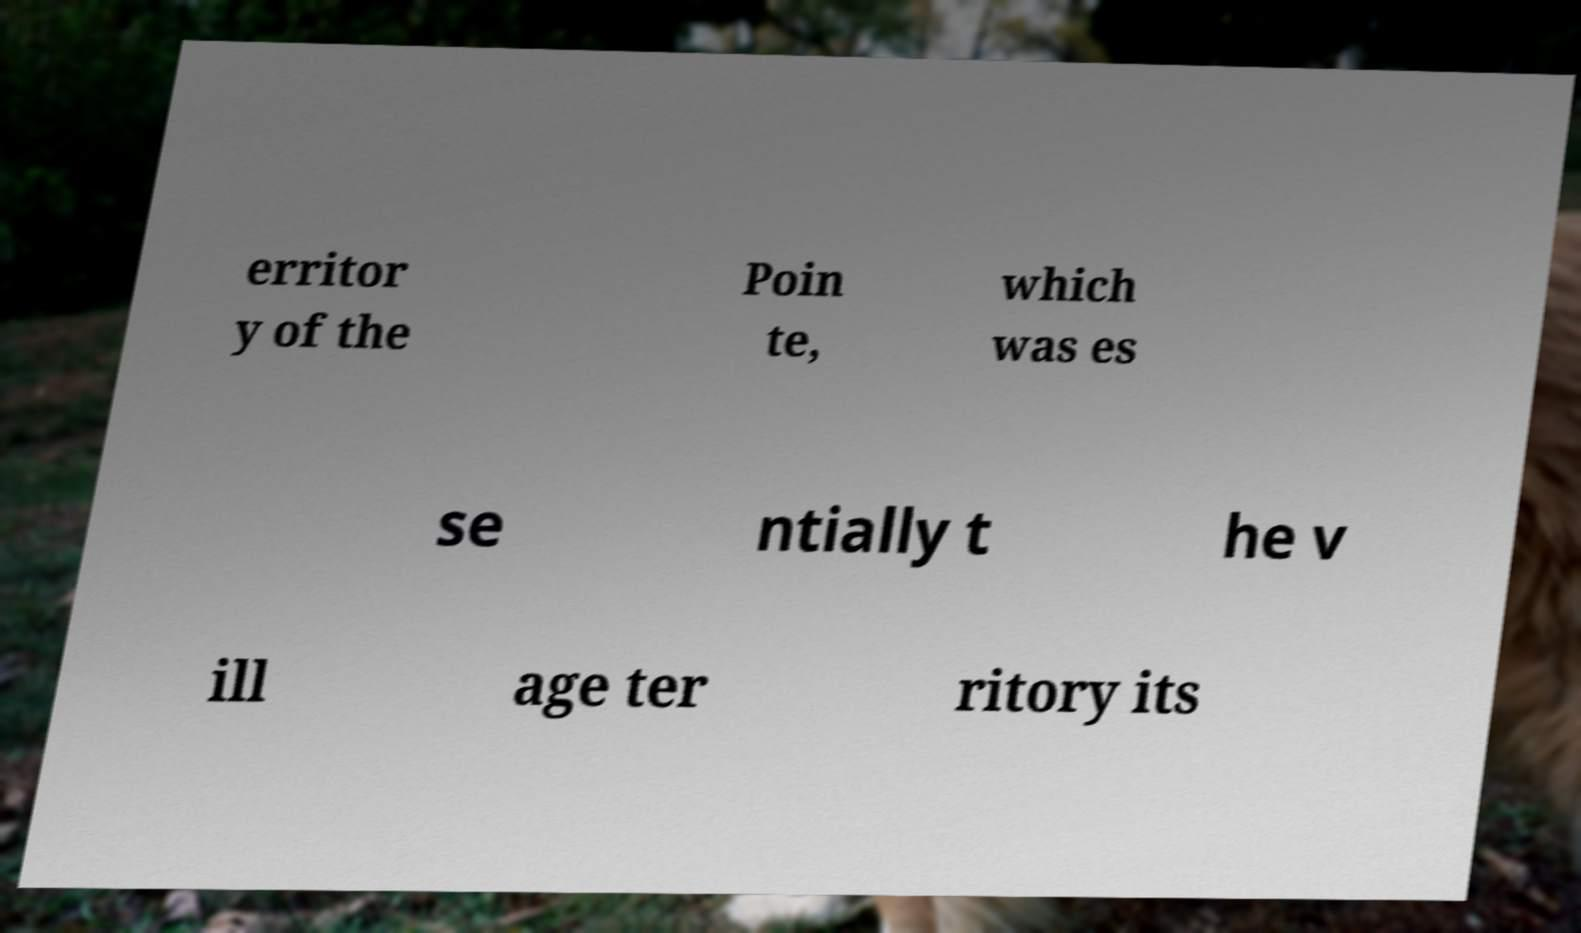For documentation purposes, I need the text within this image transcribed. Could you provide that? erritor y of the Poin te, which was es se ntially t he v ill age ter ritory its 